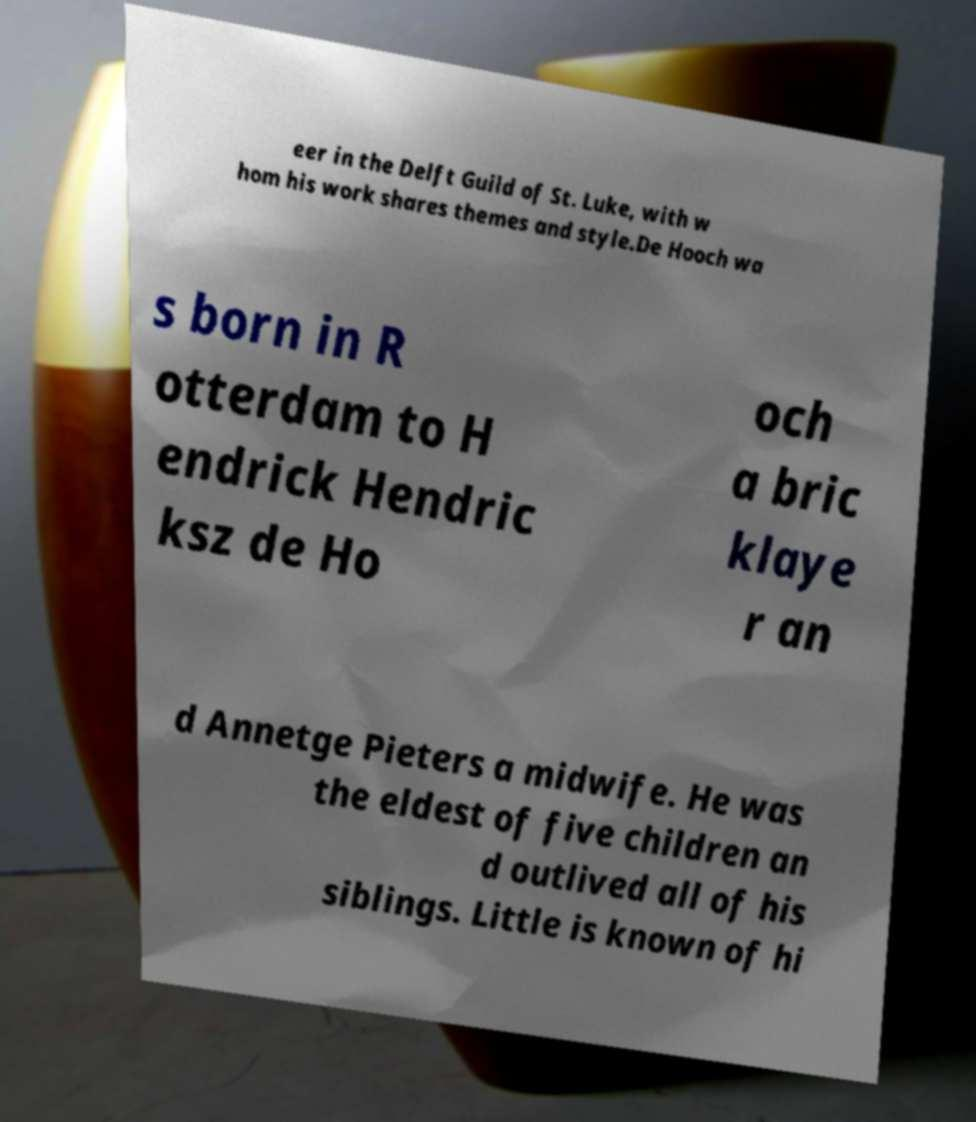Could you extract and type out the text from this image? eer in the Delft Guild of St. Luke, with w hom his work shares themes and style.De Hooch wa s born in R otterdam to H endrick Hendric ksz de Ho och a bric klaye r an d Annetge Pieters a midwife. He was the eldest of five children an d outlived all of his siblings. Little is known of hi 